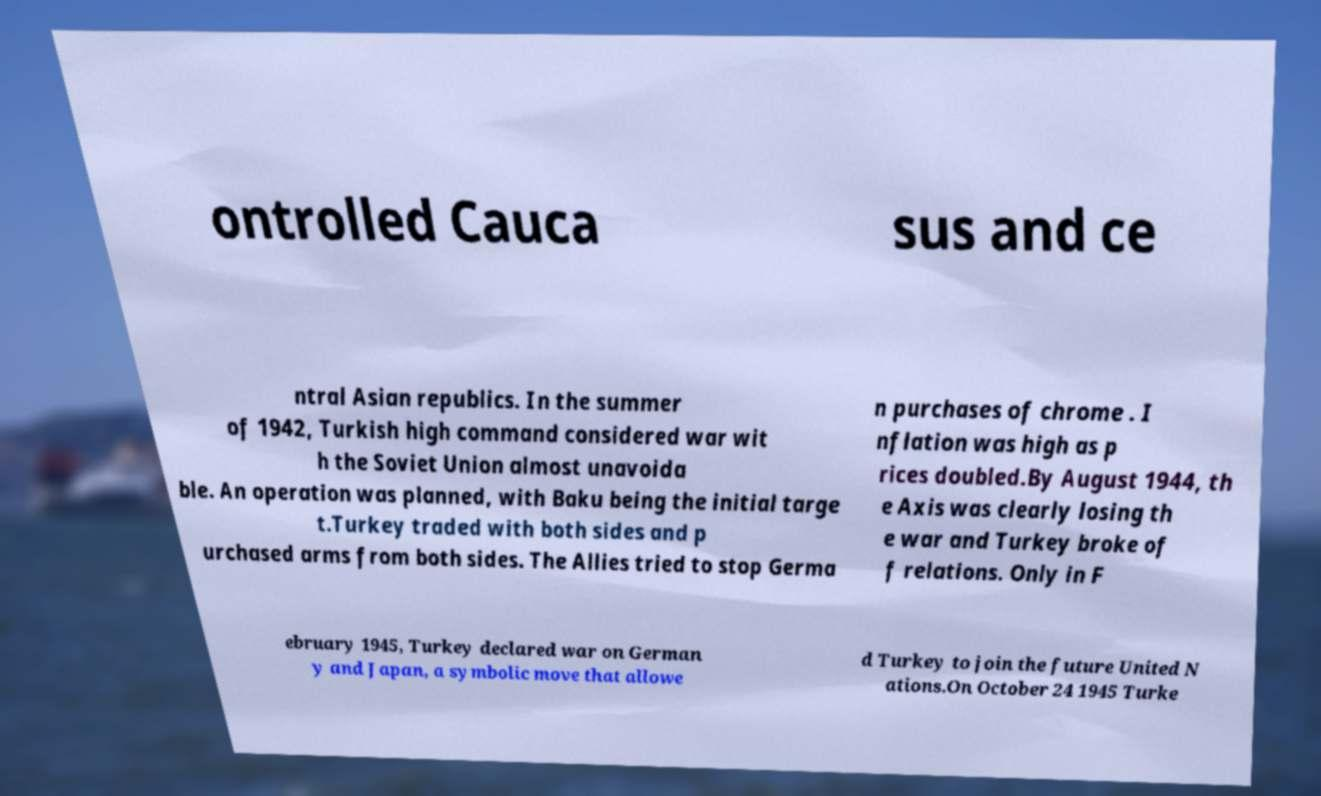For documentation purposes, I need the text within this image transcribed. Could you provide that? ontrolled Cauca sus and ce ntral Asian republics. In the summer of 1942, Turkish high command considered war wit h the Soviet Union almost unavoida ble. An operation was planned, with Baku being the initial targe t.Turkey traded with both sides and p urchased arms from both sides. The Allies tried to stop Germa n purchases of chrome . I nflation was high as p rices doubled.By August 1944, th e Axis was clearly losing th e war and Turkey broke of f relations. Only in F ebruary 1945, Turkey declared war on German y and Japan, a symbolic move that allowe d Turkey to join the future United N ations.On October 24 1945 Turke 